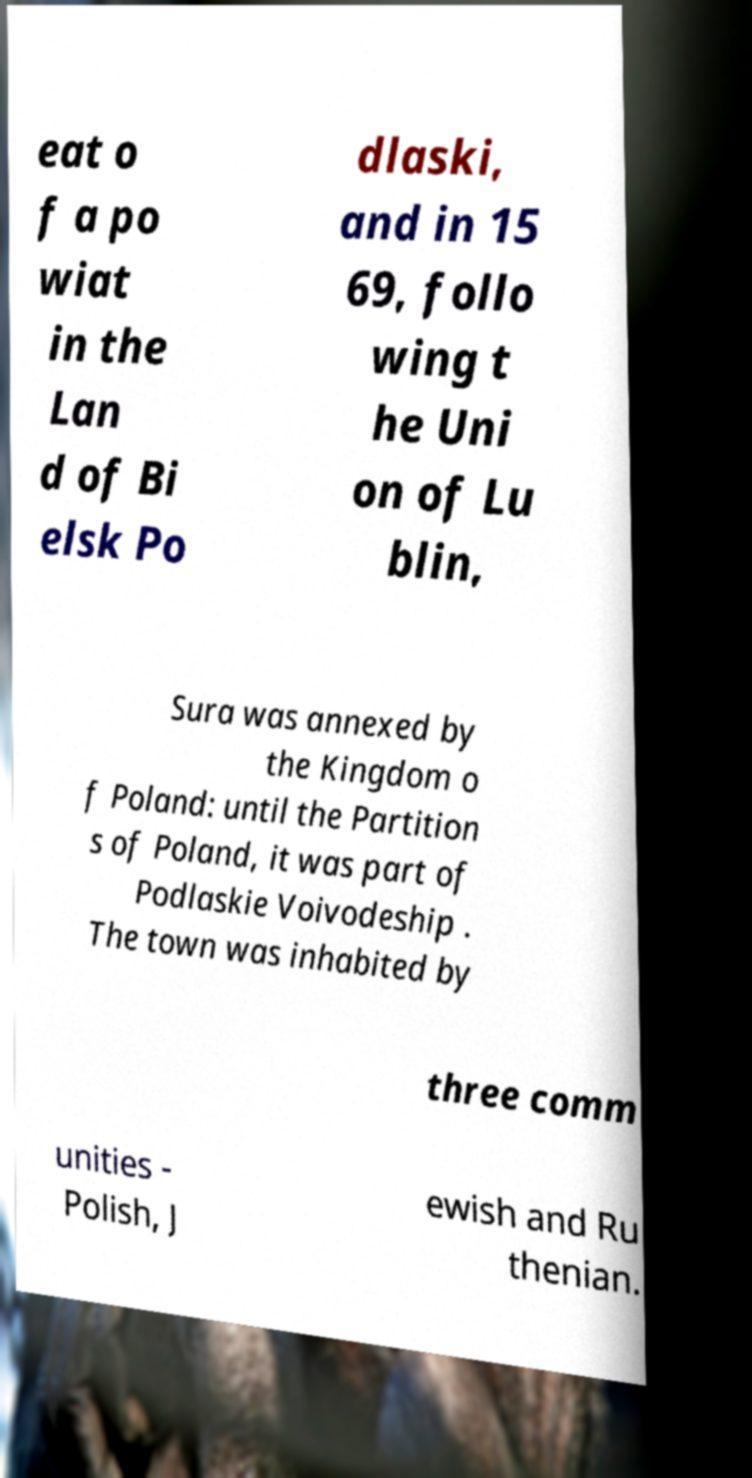For documentation purposes, I need the text within this image transcribed. Could you provide that? eat o f a po wiat in the Lan d of Bi elsk Po dlaski, and in 15 69, follo wing t he Uni on of Lu blin, Sura was annexed by the Kingdom o f Poland: until the Partition s of Poland, it was part of Podlaskie Voivodeship . The town was inhabited by three comm unities - Polish, J ewish and Ru thenian. 